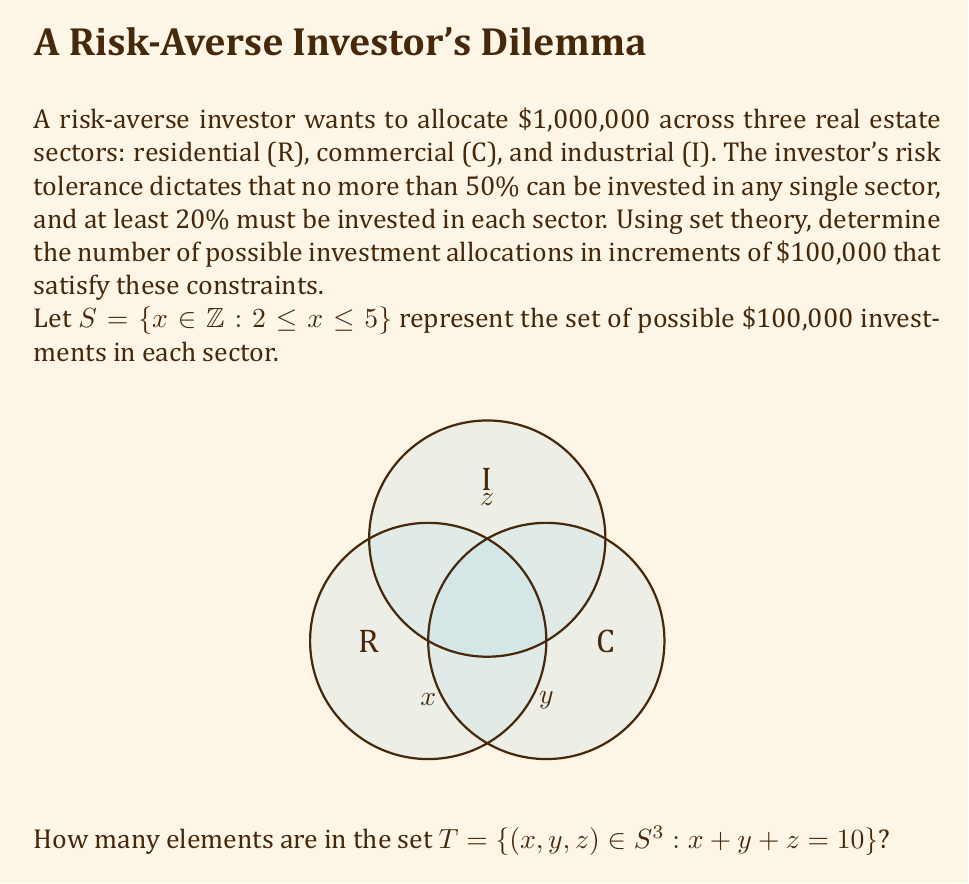Help me with this question. Let's approach this step-by-step:

1) First, we need to understand what the set $S$ represents:
   $S = \{2, 3, 4, 5\}$
   This means each sector can receive 2, 3, 4, or 5 hundred thousand dollars.

2) The set $T$ represents all possible combinations $(x,y,z)$ where:
   - $x, y, z \in S$
   - $x + y + z = 10$ (because the total investment is $1,000,000)

3) The constraints are already built into the set $S$:
   - At least 20% in each sector: $2 \leq x, y, z$
   - No more than 50% in any sector: $x, y, z \leq 5$

4) Now, we need to find all combinations of $x, y, z$ from $S$ that sum to 10.

5) Let's list all possibilities:
   $(2, 3, 5)$, $(2, 4, 4)$, $(2, 5, 3)$
   $(3, 2, 5)$, $(3, 3, 4)$, $(3, 4, 3)$, $(3, 5, 2)$
   $(4, 2, 4)$, $(4, 3, 3)$, $(4, 4, 2)$
   $(5, 2, 3)$, $(5, 3, 2)$

6) Counting these combinations, we find that there are 12 elements in set $T$.
Answer: 12 